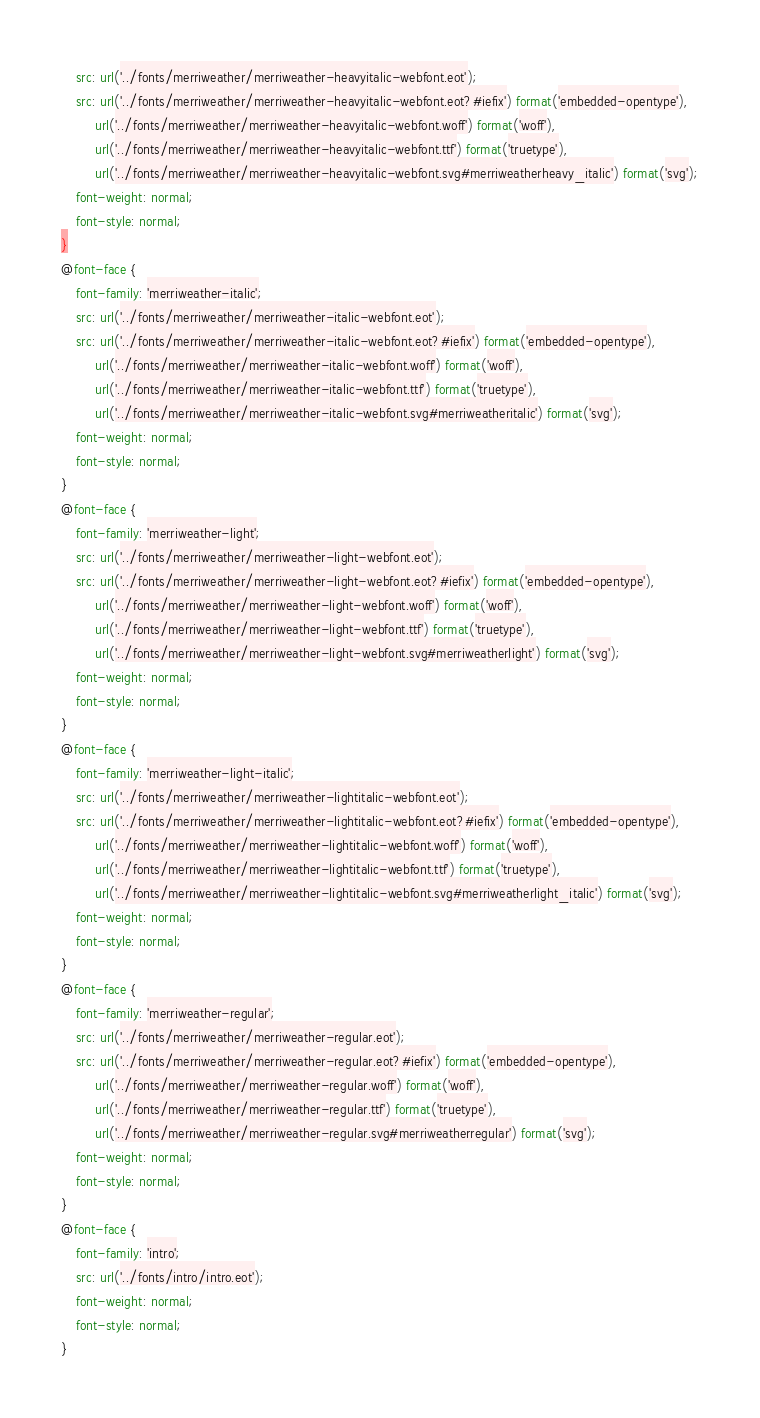Convert code to text. <code><loc_0><loc_0><loc_500><loc_500><_CSS_>    src: url('../fonts/merriweather/merriweather-heavyitalic-webfont.eot');
    src: url('../fonts/merriweather/merriweather-heavyitalic-webfont.eot?#iefix') format('embedded-opentype'),
         url('../fonts/merriweather/merriweather-heavyitalic-webfont.woff') format('woff'),
         url('../fonts/merriweather/merriweather-heavyitalic-webfont.ttf') format('truetype'),
         url('../fonts/merriweather/merriweather-heavyitalic-webfont.svg#merriweatherheavy_italic') format('svg');
    font-weight: normal;
    font-style: normal;
}
@font-face {
    font-family: 'merriweather-italic';
    src: url('../fonts/merriweather/merriweather-italic-webfont.eot');
    src: url('../fonts/merriweather/merriweather-italic-webfont.eot?#iefix') format('embedded-opentype'),
         url('../fonts/merriweather/merriweather-italic-webfont.woff') format('woff'),
         url('../fonts/merriweather/merriweather-italic-webfont.ttf') format('truetype'),
         url('../fonts/merriweather/merriweather-italic-webfont.svg#merriweatheritalic') format('svg');
    font-weight: normal;
    font-style: normal;
}
@font-face {
    font-family: 'merriweather-light';
    src: url('../fonts/merriweather/merriweather-light-webfont.eot');
    src: url('../fonts/merriweather/merriweather-light-webfont.eot?#iefix') format('embedded-opentype'),
         url('../fonts/merriweather/merriweather-light-webfont.woff') format('woff'),
         url('../fonts/merriweather/merriweather-light-webfont.ttf') format('truetype'),
         url('../fonts/merriweather/merriweather-light-webfont.svg#merriweatherlight') format('svg');
    font-weight: normal;
    font-style: normal;
}
@font-face {
    font-family: 'merriweather-light-italic';
    src: url('../fonts/merriweather/merriweather-lightitalic-webfont.eot');
    src: url('../fonts/merriweather/merriweather-lightitalic-webfont.eot?#iefix') format('embedded-opentype'),
         url('../fonts/merriweather/merriweather-lightitalic-webfont.woff') format('woff'),
         url('../fonts/merriweather/merriweather-lightitalic-webfont.ttf') format('truetype'),
         url('../fonts/merriweather/merriweather-lightitalic-webfont.svg#merriweatherlight_italic') format('svg');
    font-weight: normal;
    font-style: normal;
}
@font-face {
    font-family: 'merriweather-regular';
    src: url('../fonts/merriweather/merriweather-regular.eot');
    src: url('../fonts/merriweather/merriweather-regular.eot?#iefix') format('embedded-opentype'),
         url('../fonts/merriweather/merriweather-regular.woff') format('woff'),
         url('../fonts/merriweather/merriweather-regular.ttf') format('truetype'),
         url('../fonts/merriweather/merriweather-regular.svg#merriweatherregular') format('svg');
    font-weight: normal;
    font-style: normal;
}
@font-face {
    font-family: 'intro';
    src: url('../fonts/intro/intro.eot');
    font-weight: normal;
    font-style: normal;
}

</code> 